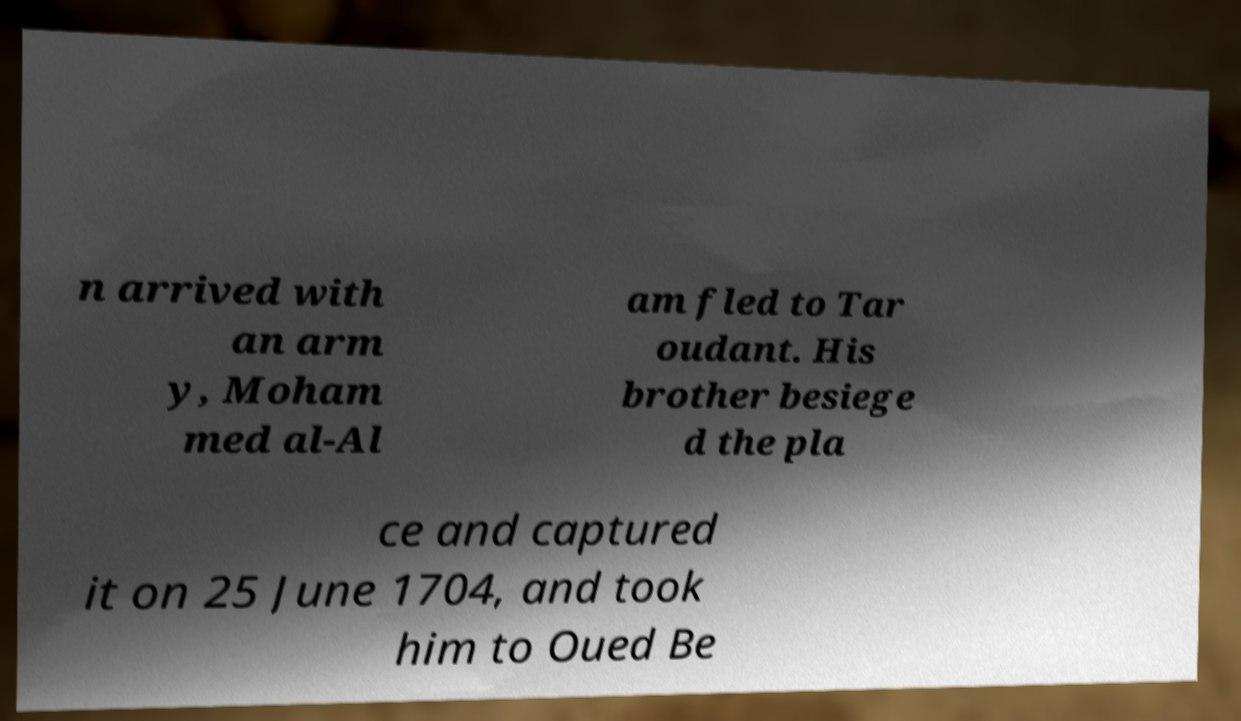Please identify and transcribe the text found in this image. n arrived with an arm y, Moham med al-Al am fled to Tar oudant. His brother besiege d the pla ce and captured it on 25 June 1704, and took him to Oued Be 